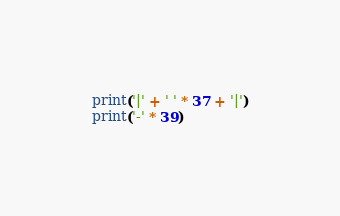Convert code to text. <code><loc_0><loc_0><loc_500><loc_500><_Python_>print('|' + ' ' * 37 + '|')
print('-' * 39)
</code> 